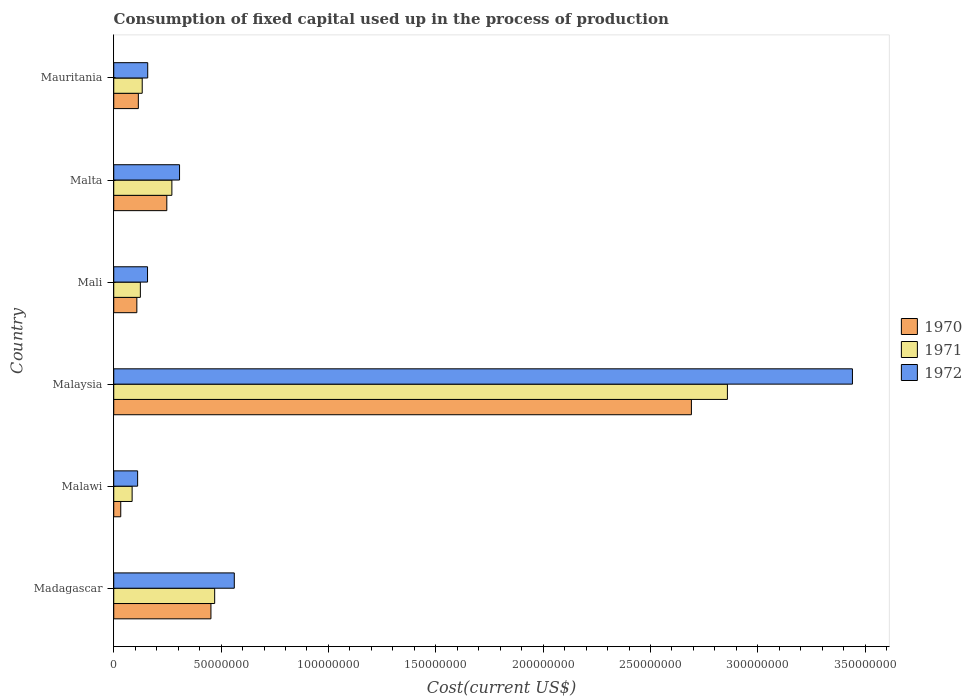How many bars are there on the 2nd tick from the top?
Offer a very short reply. 3. What is the label of the 2nd group of bars from the top?
Ensure brevity in your answer.  Malta. In how many cases, is the number of bars for a given country not equal to the number of legend labels?
Offer a very short reply. 0. What is the amount consumed in the process of production in 1972 in Mauritania?
Offer a terse response. 1.58e+07. Across all countries, what is the maximum amount consumed in the process of production in 1972?
Make the answer very short. 3.44e+08. Across all countries, what is the minimum amount consumed in the process of production in 1971?
Make the answer very short. 8.56e+06. In which country was the amount consumed in the process of production in 1972 maximum?
Provide a succinct answer. Malaysia. In which country was the amount consumed in the process of production in 1970 minimum?
Give a very brief answer. Malawi. What is the total amount consumed in the process of production in 1970 in the graph?
Keep it short and to the point. 3.65e+08. What is the difference between the amount consumed in the process of production in 1972 in Malaysia and that in Mali?
Make the answer very short. 3.28e+08. What is the difference between the amount consumed in the process of production in 1971 in Malawi and the amount consumed in the process of production in 1972 in Malaysia?
Provide a succinct answer. -3.35e+08. What is the average amount consumed in the process of production in 1970 per country?
Keep it short and to the point. 6.08e+07. What is the difference between the amount consumed in the process of production in 1972 and amount consumed in the process of production in 1971 in Malta?
Ensure brevity in your answer.  3.58e+06. In how many countries, is the amount consumed in the process of production in 1970 greater than 210000000 US$?
Your answer should be very brief. 1. What is the ratio of the amount consumed in the process of production in 1971 in Madagascar to that in Mauritania?
Offer a very short reply. 3.54. Is the amount consumed in the process of production in 1972 in Malaysia less than that in Mali?
Offer a terse response. No. Is the difference between the amount consumed in the process of production in 1972 in Madagascar and Mali greater than the difference between the amount consumed in the process of production in 1971 in Madagascar and Mali?
Offer a terse response. Yes. What is the difference between the highest and the second highest amount consumed in the process of production in 1970?
Provide a succinct answer. 2.24e+08. What is the difference between the highest and the lowest amount consumed in the process of production in 1971?
Offer a very short reply. 2.77e+08. What does the 2nd bar from the bottom in Mali represents?
Offer a terse response. 1971. Is it the case that in every country, the sum of the amount consumed in the process of production in 1970 and amount consumed in the process of production in 1972 is greater than the amount consumed in the process of production in 1971?
Provide a short and direct response. Yes. Are all the bars in the graph horizontal?
Keep it short and to the point. Yes. Are the values on the major ticks of X-axis written in scientific E-notation?
Provide a succinct answer. No. Does the graph contain any zero values?
Your answer should be compact. No. How are the legend labels stacked?
Offer a terse response. Vertical. What is the title of the graph?
Provide a short and direct response. Consumption of fixed capital used up in the process of production. Does "1992" appear as one of the legend labels in the graph?
Offer a terse response. No. What is the label or title of the X-axis?
Offer a very short reply. Cost(current US$). What is the Cost(current US$) in 1970 in Madagascar?
Give a very brief answer. 4.53e+07. What is the Cost(current US$) in 1971 in Madagascar?
Keep it short and to the point. 4.70e+07. What is the Cost(current US$) of 1972 in Madagascar?
Provide a succinct answer. 5.61e+07. What is the Cost(current US$) in 1970 in Malawi?
Your answer should be compact. 3.26e+06. What is the Cost(current US$) of 1971 in Malawi?
Offer a very short reply. 8.56e+06. What is the Cost(current US$) in 1972 in Malawi?
Provide a short and direct response. 1.11e+07. What is the Cost(current US$) in 1970 in Malaysia?
Your answer should be very brief. 2.69e+08. What is the Cost(current US$) of 1971 in Malaysia?
Give a very brief answer. 2.86e+08. What is the Cost(current US$) in 1972 in Malaysia?
Provide a short and direct response. 3.44e+08. What is the Cost(current US$) in 1970 in Mali?
Provide a succinct answer. 1.08e+07. What is the Cost(current US$) of 1971 in Mali?
Offer a terse response. 1.24e+07. What is the Cost(current US$) in 1972 in Mali?
Keep it short and to the point. 1.57e+07. What is the Cost(current US$) of 1970 in Malta?
Your response must be concise. 2.47e+07. What is the Cost(current US$) in 1971 in Malta?
Your answer should be very brief. 2.71e+07. What is the Cost(current US$) of 1972 in Malta?
Keep it short and to the point. 3.06e+07. What is the Cost(current US$) in 1970 in Mauritania?
Your answer should be very brief. 1.15e+07. What is the Cost(current US$) in 1971 in Mauritania?
Provide a succinct answer. 1.33e+07. What is the Cost(current US$) in 1972 in Mauritania?
Offer a very short reply. 1.58e+07. Across all countries, what is the maximum Cost(current US$) of 1970?
Provide a succinct answer. 2.69e+08. Across all countries, what is the maximum Cost(current US$) of 1971?
Your answer should be compact. 2.86e+08. Across all countries, what is the maximum Cost(current US$) in 1972?
Provide a short and direct response. 3.44e+08. Across all countries, what is the minimum Cost(current US$) in 1970?
Make the answer very short. 3.26e+06. Across all countries, what is the minimum Cost(current US$) of 1971?
Keep it short and to the point. 8.56e+06. Across all countries, what is the minimum Cost(current US$) in 1972?
Offer a very short reply. 1.11e+07. What is the total Cost(current US$) of 1970 in the graph?
Your response must be concise. 3.65e+08. What is the total Cost(current US$) of 1971 in the graph?
Ensure brevity in your answer.  3.94e+08. What is the total Cost(current US$) in 1972 in the graph?
Ensure brevity in your answer.  4.74e+08. What is the difference between the Cost(current US$) of 1970 in Madagascar and that in Malawi?
Keep it short and to the point. 4.20e+07. What is the difference between the Cost(current US$) in 1971 in Madagascar and that in Malawi?
Your answer should be compact. 3.84e+07. What is the difference between the Cost(current US$) in 1972 in Madagascar and that in Malawi?
Ensure brevity in your answer.  4.50e+07. What is the difference between the Cost(current US$) of 1970 in Madagascar and that in Malaysia?
Keep it short and to the point. -2.24e+08. What is the difference between the Cost(current US$) in 1971 in Madagascar and that in Malaysia?
Your response must be concise. -2.39e+08. What is the difference between the Cost(current US$) of 1972 in Madagascar and that in Malaysia?
Ensure brevity in your answer.  -2.88e+08. What is the difference between the Cost(current US$) of 1970 in Madagascar and that in Mali?
Keep it short and to the point. 3.45e+07. What is the difference between the Cost(current US$) in 1971 in Madagascar and that in Mali?
Give a very brief answer. 3.46e+07. What is the difference between the Cost(current US$) of 1972 in Madagascar and that in Mali?
Keep it short and to the point. 4.04e+07. What is the difference between the Cost(current US$) in 1970 in Madagascar and that in Malta?
Make the answer very short. 2.06e+07. What is the difference between the Cost(current US$) in 1971 in Madagascar and that in Malta?
Make the answer very short. 1.99e+07. What is the difference between the Cost(current US$) in 1972 in Madagascar and that in Malta?
Offer a terse response. 2.55e+07. What is the difference between the Cost(current US$) of 1970 in Madagascar and that in Mauritania?
Provide a short and direct response. 3.38e+07. What is the difference between the Cost(current US$) of 1971 in Madagascar and that in Mauritania?
Your response must be concise. 3.37e+07. What is the difference between the Cost(current US$) in 1972 in Madagascar and that in Mauritania?
Ensure brevity in your answer.  4.03e+07. What is the difference between the Cost(current US$) in 1970 in Malawi and that in Malaysia?
Your answer should be very brief. -2.66e+08. What is the difference between the Cost(current US$) of 1971 in Malawi and that in Malaysia?
Ensure brevity in your answer.  -2.77e+08. What is the difference between the Cost(current US$) of 1972 in Malawi and that in Malaysia?
Keep it short and to the point. -3.33e+08. What is the difference between the Cost(current US$) of 1970 in Malawi and that in Mali?
Ensure brevity in your answer.  -7.50e+06. What is the difference between the Cost(current US$) of 1971 in Malawi and that in Mali?
Your answer should be compact. -3.83e+06. What is the difference between the Cost(current US$) in 1972 in Malawi and that in Mali?
Keep it short and to the point. -4.62e+06. What is the difference between the Cost(current US$) in 1970 in Malawi and that in Malta?
Your answer should be compact. -2.15e+07. What is the difference between the Cost(current US$) in 1971 in Malawi and that in Malta?
Your answer should be compact. -1.85e+07. What is the difference between the Cost(current US$) in 1972 in Malawi and that in Malta?
Ensure brevity in your answer.  -1.95e+07. What is the difference between the Cost(current US$) of 1970 in Malawi and that in Mauritania?
Offer a terse response. -8.20e+06. What is the difference between the Cost(current US$) of 1971 in Malawi and that in Mauritania?
Provide a succinct answer. -4.70e+06. What is the difference between the Cost(current US$) in 1972 in Malawi and that in Mauritania?
Your response must be concise. -4.70e+06. What is the difference between the Cost(current US$) of 1970 in Malaysia and that in Mali?
Your answer should be compact. 2.58e+08. What is the difference between the Cost(current US$) in 1971 in Malaysia and that in Mali?
Offer a terse response. 2.73e+08. What is the difference between the Cost(current US$) of 1972 in Malaysia and that in Mali?
Provide a succinct answer. 3.28e+08. What is the difference between the Cost(current US$) in 1970 in Malaysia and that in Malta?
Keep it short and to the point. 2.44e+08. What is the difference between the Cost(current US$) of 1971 in Malaysia and that in Malta?
Provide a short and direct response. 2.59e+08. What is the difference between the Cost(current US$) of 1972 in Malaysia and that in Malta?
Keep it short and to the point. 3.13e+08. What is the difference between the Cost(current US$) in 1970 in Malaysia and that in Mauritania?
Offer a very short reply. 2.58e+08. What is the difference between the Cost(current US$) of 1971 in Malaysia and that in Mauritania?
Keep it short and to the point. 2.73e+08. What is the difference between the Cost(current US$) in 1972 in Malaysia and that in Mauritania?
Give a very brief answer. 3.28e+08. What is the difference between the Cost(current US$) in 1970 in Mali and that in Malta?
Your answer should be very brief. -1.40e+07. What is the difference between the Cost(current US$) in 1971 in Mali and that in Malta?
Your response must be concise. -1.47e+07. What is the difference between the Cost(current US$) in 1972 in Mali and that in Malta?
Offer a terse response. -1.49e+07. What is the difference between the Cost(current US$) of 1970 in Mali and that in Mauritania?
Make the answer very short. -6.96e+05. What is the difference between the Cost(current US$) in 1971 in Mali and that in Mauritania?
Make the answer very short. -8.66e+05. What is the difference between the Cost(current US$) in 1972 in Mali and that in Mauritania?
Your response must be concise. -8.44e+04. What is the difference between the Cost(current US$) in 1970 in Malta and that in Mauritania?
Keep it short and to the point. 1.33e+07. What is the difference between the Cost(current US$) in 1971 in Malta and that in Mauritania?
Keep it short and to the point. 1.38e+07. What is the difference between the Cost(current US$) in 1972 in Malta and that in Mauritania?
Give a very brief answer. 1.48e+07. What is the difference between the Cost(current US$) in 1970 in Madagascar and the Cost(current US$) in 1971 in Malawi?
Your answer should be compact. 3.67e+07. What is the difference between the Cost(current US$) of 1970 in Madagascar and the Cost(current US$) of 1972 in Malawi?
Your answer should be compact. 3.41e+07. What is the difference between the Cost(current US$) in 1971 in Madagascar and the Cost(current US$) in 1972 in Malawi?
Ensure brevity in your answer.  3.59e+07. What is the difference between the Cost(current US$) in 1970 in Madagascar and the Cost(current US$) in 1971 in Malaysia?
Give a very brief answer. -2.41e+08. What is the difference between the Cost(current US$) of 1970 in Madagascar and the Cost(current US$) of 1972 in Malaysia?
Make the answer very short. -2.99e+08. What is the difference between the Cost(current US$) in 1971 in Madagascar and the Cost(current US$) in 1972 in Malaysia?
Your answer should be compact. -2.97e+08. What is the difference between the Cost(current US$) of 1970 in Madagascar and the Cost(current US$) of 1971 in Mali?
Your response must be concise. 3.29e+07. What is the difference between the Cost(current US$) in 1970 in Madagascar and the Cost(current US$) in 1972 in Mali?
Your response must be concise. 2.95e+07. What is the difference between the Cost(current US$) of 1971 in Madagascar and the Cost(current US$) of 1972 in Mali?
Make the answer very short. 3.13e+07. What is the difference between the Cost(current US$) of 1970 in Madagascar and the Cost(current US$) of 1971 in Malta?
Ensure brevity in your answer.  1.82e+07. What is the difference between the Cost(current US$) in 1970 in Madagascar and the Cost(current US$) in 1972 in Malta?
Offer a very short reply. 1.46e+07. What is the difference between the Cost(current US$) in 1971 in Madagascar and the Cost(current US$) in 1972 in Malta?
Offer a terse response. 1.64e+07. What is the difference between the Cost(current US$) of 1970 in Madagascar and the Cost(current US$) of 1971 in Mauritania?
Keep it short and to the point. 3.20e+07. What is the difference between the Cost(current US$) in 1970 in Madagascar and the Cost(current US$) in 1972 in Mauritania?
Offer a terse response. 2.94e+07. What is the difference between the Cost(current US$) of 1971 in Madagascar and the Cost(current US$) of 1972 in Mauritania?
Provide a succinct answer. 3.12e+07. What is the difference between the Cost(current US$) of 1970 in Malawi and the Cost(current US$) of 1971 in Malaysia?
Your response must be concise. -2.83e+08. What is the difference between the Cost(current US$) in 1970 in Malawi and the Cost(current US$) in 1972 in Malaysia?
Make the answer very short. -3.41e+08. What is the difference between the Cost(current US$) of 1971 in Malawi and the Cost(current US$) of 1972 in Malaysia?
Your response must be concise. -3.35e+08. What is the difference between the Cost(current US$) of 1970 in Malawi and the Cost(current US$) of 1971 in Mali?
Provide a succinct answer. -9.13e+06. What is the difference between the Cost(current US$) of 1970 in Malawi and the Cost(current US$) of 1972 in Mali?
Provide a succinct answer. -1.25e+07. What is the difference between the Cost(current US$) of 1971 in Malawi and the Cost(current US$) of 1972 in Mali?
Your answer should be very brief. -7.18e+06. What is the difference between the Cost(current US$) in 1970 in Malawi and the Cost(current US$) in 1971 in Malta?
Keep it short and to the point. -2.38e+07. What is the difference between the Cost(current US$) of 1970 in Malawi and the Cost(current US$) of 1972 in Malta?
Your answer should be very brief. -2.74e+07. What is the difference between the Cost(current US$) in 1971 in Malawi and the Cost(current US$) in 1972 in Malta?
Make the answer very short. -2.21e+07. What is the difference between the Cost(current US$) in 1970 in Malawi and the Cost(current US$) in 1971 in Mauritania?
Make the answer very short. -1.00e+07. What is the difference between the Cost(current US$) in 1970 in Malawi and the Cost(current US$) in 1972 in Mauritania?
Offer a terse response. -1.26e+07. What is the difference between the Cost(current US$) in 1971 in Malawi and the Cost(current US$) in 1972 in Mauritania?
Offer a very short reply. -7.26e+06. What is the difference between the Cost(current US$) in 1970 in Malaysia and the Cost(current US$) in 1971 in Mali?
Give a very brief answer. 2.57e+08. What is the difference between the Cost(current US$) in 1970 in Malaysia and the Cost(current US$) in 1972 in Mali?
Provide a succinct answer. 2.53e+08. What is the difference between the Cost(current US$) of 1971 in Malaysia and the Cost(current US$) of 1972 in Mali?
Your response must be concise. 2.70e+08. What is the difference between the Cost(current US$) of 1970 in Malaysia and the Cost(current US$) of 1971 in Malta?
Offer a very short reply. 2.42e+08. What is the difference between the Cost(current US$) of 1970 in Malaysia and the Cost(current US$) of 1972 in Malta?
Give a very brief answer. 2.38e+08. What is the difference between the Cost(current US$) in 1971 in Malaysia and the Cost(current US$) in 1972 in Malta?
Ensure brevity in your answer.  2.55e+08. What is the difference between the Cost(current US$) in 1970 in Malaysia and the Cost(current US$) in 1971 in Mauritania?
Make the answer very short. 2.56e+08. What is the difference between the Cost(current US$) of 1970 in Malaysia and the Cost(current US$) of 1972 in Mauritania?
Your response must be concise. 2.53e+08. What is the difference between the Cost(current US$) in 1971 in Malaysia and the Cost(current US$) in 1972 in Mauritania?
Your answer should be very brief. 2.70e+08. What is the difference between the Cost(current US$) in 1970 in Mali and the Cost(current US$) in 1971 in Malta?
Keep it short and to the point. -1.63e+07. What is the difference between the Cost(current US$) of 1970 in Mali and the Cost(current US$) of 1972 in Malta?
Your response must be concise. -1.99e+07. What is the difference between the Cost(current US$) of 1971 in Mali and the Cost(current US$) of 1972 in Malta?
Offer a terse response. -1.83e+07. What is the difference between the Cost(current US$) of 1970 in Mali and the Cost(current US$) of 1971 in Mauritania?
Provide a short and direct response. -2.50e+06. What is the difference between the Cost(current US$) of 1970 in Mali and the Cost(current US$) of 1972 in Mauritania?
Provide a short and direct response. -5.06e+06. What is the difference between the Cost(current US$) in 1971 in Mali and the Cost(current US$) in 1972 in Mauritania?
Provide a succinct answer. -3.43e+06. What is the difference between the Cost(current US$) in 1970 in Malta and the Cost(current US$) in 1971 in Mauritania?
Your answer should be very brief. 1.15e+07. What is the difference between the Cost(current US$) of 1970 in Malta and the Cost(current US$) of 1972 in Mauritania?
Your response must be concise. 8.89e+06. What is the difference between the Cost(current US$) in 1971 in Malta and the Cost(current US$) in 1972 in Mauritania?
Provide a succinct answer. 1.12e+07. What is the average Cost(current US$) of 1970 per country?
Make the answer very short. 6.08e+07. What is the average Cost(current US$) of 1971 per country?
Offer a terse response. 6.57e+07. What is the average Cost(current US$) in 1972 per country?
Offer a terse response. 7.89e+07. What is the difference between the Cost(current US$) in 1970 and Cost(current US$) in 1971 in Madagascar?
Offer a very short reply. -1.74e+06. What is the difference between the Cost(current US$) of 1970 and Cost(current US$) of 1972 in Madagascar?
Offer a terse response. -1.09e+07. What is the difference between the Cost(current US$) in 1971 and Cost(current US$) in 1972 in Madagascar?
Offer a very short reply. -9.14e+06. What is the difference between the Cost(current US$) in 1970 and Cost(current US$) in 1971 in Malawi?
Provide a succinct answer. -5.30e+06. What is the difference between the Cost(current US$) in 1970 and Cost(current US$) in 1972 in Malawi?
Give a very brief answer. -7.86e+06. What is the difference between the Cost(current US$) of 1971 and Cost(current US$) of 1972 in Malawi?
Make the answer very short. -2.56e+06. What is the difference between the Cost(current US$) in 1970 and Cost(current US$) in 1971 in Malaysia?
Ensure brevity in your answer.  -1.68e+07. What is the difference between the Cost(current US$) of 1970 and Cost(current US$) of 1972 in Malaysia?
Your response must be concise. -7.50e+07. What is the difference between the Cost(current US$) in 1971 and Cost(current US$) in 1972 in Malaysia?
Provide a succinct answer. -5.82e+07. What is the difference between the Cost(current US$) of 1970 and Cost(current US$) of 1971 in Mali?
Keep it short and to the point. -1.63e+06. What is the difference between the Cost(current US$) of 1970 and Cost(current US$) of 1972 in Mali?
Make the answer very short. -4.98e+06. What is the difference between the Cost(current US$) in 1971 and Cost(current US$) in 1972 in Mali?
Give a very brief answer. -3.35e+06. What is the difference between the Cost(current US$) in 1970 and Cost(current US$) in 1971 in Malta?
Offer a terse response. -2.36e+06. What is the difference between the Cost(current US$) of 1970 and Cost(current US$) of 1972 in Malta?
Provide a short and direct response. -5.93e+06. What is the difference between the Cost(current US$) in 1971 and Cost(current US$) in 1972 in Malta?
Keep it short and to the point. -3.58e+06. What is the difference between the Cost(current US$) in 1970 and Cost(current US$) in 1971 in Mauritania?
Offer a very short reply. -1.80e+06. What is the difference between the Cost(current US$) of 1970 and Cost(current US$) of 1972 in Mauritania?
Your answer should be compact. -4.37e+06. What is the difference between the Cost(current US$) of 1971 and Cost(current US$) of 1972 in Mauritania?
Offer a very short reply. -2.57e+06. What is the ratio of the Cost(current US$) in 1970 in Madagascar to that in Malawi?
Keep it short and to the point. 13.88. What is the ratio of the Cost(current US$) of 1971 in Madagascar to that in Malawi?
Ensure brevity in your answer.  5.49. What is the ratio of the Cost(current US$) of 1972 in Madagascar to that in Malawi?
Provide a succinct answer. 5.05. What is the ratio of the Cost(current US$) of 1970 in Madagascar to that in Malaysia?
Offer a very short reply. 0.17. What is the ratio of the Cost(current US$) in 1971 in Madagascar to that in Malaysia?
Offer a terse response. 0.16. What is the ratio of the Cost(current US$) of 1972 in Madagascar to that in Malaysia?
Make the answer very short. 0.16. What is the ratio of the Cost(current US$) in 1970 in Madagascar to that in Mali?
Provide a succinct answer. 4.21. What is the ratio of the Cost(current US$) of 1971 in Madagascar to that in Mali?
Give a very brief answer. 3.79. What is the ratio of the Cost(current US$) of 1972 in Madagascar to that in Mali?
Offer a very short reply. 3.57. What is the ratio of the Cost(current US$) of 1970 in Madagascar to that in Malta?
Your answer should be very brief. 1.83. What is the ratio of the Cost(current US$) in 1971 in Madagascar to that in Malta?
Give a very brief answer. 1.74. What is the ratio of the Cost(current US$) of 1972 in Madagascar to that in Malta?
Offer a terse response. 1.83. What is the ratio of the Cost(current US$) in 1970 in Madagascar to that in Mauritania?
Your answer should be very brief. 3.95. What is the ratio of the Cost(current US$) in 1971 in Madagascar to that in Mauritania?
Offer a terse response. 3.54. What is the ratio of the Cost(current US$) in 1972 in Madagascar to that in Mauritania?
Keep it short and to the point. 3.55. What is the ratio of the Cost(current US$) in 1970 in Malawi to that in Malaysia?
Provide a succinct answer. 0.01. What is the ratio of the Cost(current US$) in 1972 in Malawi to that in Malaysia?
Give a very brief answer. 0.03. What is the ratio of the Cost(current US$) of 1970 in Malawi to that in Mali?
Your response must be concise. 0.3. What is the ratio of the Cost(current US$) of 1971 in Malawi to that in Mali?
Ensure brevity in your answer.  0.69. What is the ratio of the Cost(current US$) of 1972 in Malawi to that in Mali?
Your answer should be compact. 0.71. What is the ratio of the Cost(current US$) in 1970 in Malawi to that in Malta?
Ensure brevity in your answer.  0.13. What is the ratio of the Cost(current US$) in 1971 in Malawi to that in Malta?
Your answer should be very brief. 0.32. What is the ratio of the Cost(current US$) of 1972 in Malawi to that in Malta?
Make the answer very short. 0.36. What is the ratio of the Cost(current US$) of 1970 in Malawi to that in Mauritania?
Ensure brevity in your answer.  0.28. What is the ratio of the Cost(current US$) of 1971 in Malawi to that in Mauritania?
Keep it short and to the point. 0.65. What is the ratio of the Cost(current US$) of 1972 in Malawi to that in Mauritania?
Your answer should be compact. 0.7. What is the ratio of the Cost(current US$) of 1970 in Malaysia to that in Mali?
Offer a terse response. 25. What is the ratio of the Cost(current US$) of 1971 in Malaysia to that in Mali?
Make the answer very short. 23.06. What is the ratio of the Cost(current US$) in 1972 in Malaysia to that in Mali?
Provide a short and direct response. 21.86. What is the ratio of the Cost(current US$) of 1970 in Malaysia to that in Malta?
Your answer should be very brief. 10.88. What is the ratio of the Cost(current US$) in 1971 in Malaysia to that in Malta?
Your answer should be very brief. 10.56. What is the ratio of the Cost(current US$) of 1972 in Malaysia to that in Malta?
Your answer should be very brief. 11.23. What is the ratio of the Cost(current US$) in 1970 in Malaysia to that in Mauritania?
Ensure brevity in your answer.  23.48. What is the ratio of the Cost(current US$) of 1971 in Malaysia to that in Mauritania?
Your response must be concise. 21.55. What is the ratio of the Cost(current US$) of 1972 in Malaysia to that in Mauritania?
Ensure brevity in your answer.  21.74. What is the ratio of the Cost(current US$) in 1970 in Mali to that in Malta?
Your response must be concise. 0.44. What is the ratio of the Cost(current US$) in 1971 in Mali to that in Malta?
Your answer should be compact. 0.46. What is the ratio of the Cost(current US$) of 1972 in Mali to that in Malta?
Ensure brevity in your answer.  0.51. What is the ratio of the Cost(current US$) in 1970 in Mali to that in Mauritania?
Ensure brevity in your answer.  0.94. What is the ratio of the Cost(current US$) of 1971 in Mali to that in Mauritania?
Make the answer very short. 0.93. What is the ratio of the Cost(current US$) of 1970 in Malta to that in Mauritania?
Make the answer very short. 2.16. What is the ratio of the Cost(current US$) of 1971 in Malta to that in Mauritania?
Offer a very short reply. 2.04. What is the ratio of the Cost(current US$) in 1972 in Malta to that in Mauritania?
Ensure brevity in your answer.  1.94. What is the difference between the highest and the second highest Cost(current US$) of 1970?
Your answer should be very brief. 2.24e+08. What is the difference between the highest and the second highest Cost(current US$) of 1971?
Offer a terse response. 2.39e+08. What is the difference between the highest and the second highest Cost(current US$) of 1972?
Your answer should be compact. 2.88e+08. What is the difference between the highest and the lowest Cost(current US$) of 1970?
Offer a terse response. 2.66e+08. What is the difference between the highest and the lowest Cost(current US$) in 1971?
Your response must be concise. 2.77e+08. What is the difference between the highest and the lowest Cost(current US$) in 1972?
Give a very brief answer. 3.33e+08. 